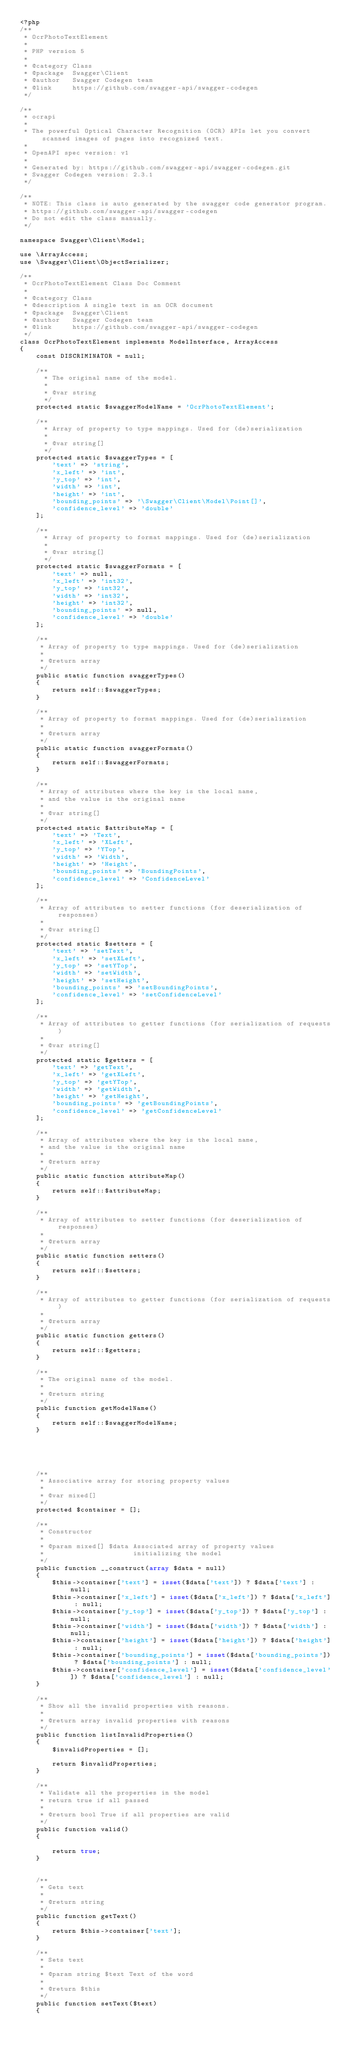Convert code to text. <code><loc_0><loc_0><loc_500><loc_500><_PHP_><?php
/**
 * OcrPhotoTextElement
 *
 * PHP version 5
 *
 * @category Class
 * @package  Swagger\Client
 * @author   Swagger Codegen team
 * @link     https://github.com/swagger-api/swagger-codegen
 */

/**
 * ocrapi
 *
 * The powerful Optical Character Recognition (OCR) APIs let you convert scanned images of pages into recognized text.
 *
 * OpenAPI spec version: v1
 * 
 * Generated by: https://github.com/swagger-api/swagger-codegen.git
 * Swagger Codegen version: 2.3.1
 */

/**
 * NOTE: This class is auto generated by the swagger code generator program.
 * https://github.com/swagger-api/swagger-codegen
 * Do not edit the class manually.
 */

namespace Swagger\Client\Model;

use \ArrayAccess;
use \Swagger\Client\ObjectSerializer;

/**
 * OcrPhotoTextElement Class Doc Comment
 *
 * @category Class
 * @description A single text in an OCR document
 * @package  Swagger\Client
 * @author   Swagger Codegen team
 * @link     https://github.com/swagger-api/swagger-codegen
 */
class OcrPhotoTextElement implements ModelInterface, ArrayAccess
{
    const DISCRIMINATOR = null;

    /**
      * The original name of the model.
      *
      * @var string
      */
    protected static $swaggerModelName = 'OcrPhotoTextElement';

    /**
      * Array of property to type mappings. Used for (de)serialization
      *
      * @var string[]
      */
    protected static $swaggerTypes = [
        'text' => 'string',
        'x_left' => 'int',
        'y_top' => 'int',
        'width' => 'int',
        'height' => 'int',
        'bounding_points' => '\Swagger\Client\Model\Point[]',
        'confidence_level' => 'double'
    ];

    /**
      * Array of property to format mappings. Used for (de)serialization
      *
      * @var string[]
      */
    protected static $swaggerFormats = [
        'text' => null,
        'x_left' => 'int32',
        'y_top' => 'int32',
        'width' => 'int32',
        'height' => 'int32',
        'bounding_points' => null,
        'confidence_level' => 'double'
    ];

    /**
     * Array of property to type mappings. Used for (de)serialization
     *
     * @return array
     */
    public static function swaggerTypes()
    {
        return self::$swaggerTypes;
    }

    /**
     * Array of property to format mappings. Used for (de)serialization
     *
     * @return array
     */
    public static function swaggerFormats()
    {
        return self::$swaggerFormats;
    }

    /**
     * Array of attributes where the key is the local name,
     * and the value is the original name
     *
     * @var string[]
     */
    protected static $attributeMap = [
        'text' => 'Text',
        'x_left' => 'XLeft',
        'y_top' => 'YTop',
        'width' => 'Width',
        'height' => 'Height',
        'bounding_points' => 'BoundingPoints',
        'confidence_level' => 'ConfidenceLevel'
    ];

    /**
     * Array of attributes to setter functions (for deserialization of responses)
     *
     * @var string[]
     */
    protected static $setters = [
        'text' => 'setText',
        'x_left' => 'setXLeft',
        'y_top' => 'setYTop',
        'width' => 'setWidth',
        'height' => 'setHeight',
        'bounding_points' => 'setBoundingPoints',
        'confidence_level' => 'setConfidenceLevel'
    ];

    /**
     * Array of attributes to getter functions (for serialization of requests)
     *
     * @var string[]
     */
    protected static $getters = [
        'text' => 'getText',
        'x_left' => 'getXLeft',
        'y_top' => 'getYTop',
        'width' => 'getWidth',
        'height' => 'getHeight',
        'bounding_points' => 'getBoundingPoints',
        'confidence_level' => 'getConfidenceLevel'
    ];

    /**
     * Array of attributes where the key is the local name,
     * and the value is the original name
     *
     * @return array
     */
    public static function attributeMap()
    {
        return self::$attributeMap;
    }

    /**
     * Array of attributes to setter functions (for deserialization of responses)
     *
     * @return array
     */
    public static function setters()
    {
        return self::$setters;
    }

    /**
     * Array of attributes to getter functions (for serialization of requests)
     *
     * @return array
     */
    public static function getters()
    {
        return self::$getters;
    }

    /**
     * The original name of the model.
     *
     * @return string
     */
    public function getModelName()
    {
        return self::$swaggerModelName;
    }

    

    

    /**
     * Associative array for storing property values
     *
     * @var mixed[]
     */
    protected $container = [];

    /**
     * Constructor
     *
     * @param mixed[] $data Associated array of property values
     *                      initializing the model
     */
    public function __construct(array $data = null)
    {
        $this->container['text'] = isset($data['text']) ? $data['text'] : null;
        $this->container['x_left'] = isset($data['x_left']) ? $data['x_left'] : null;
        $this->container['y_top'] = isset($data['y_top']) ? $data['y_top'] : null;
        $this->container['width'] = isset($data['width']) ? $data['width'] : null;
        $this->container['height'] = isset($data['height']) ? $data['height'] : null;
        $this->container['bounding_points'] = isset($data['bounding_points']) ? $data['bounding_points'] : null;
        $this->container['confidence_level'] = isset($data['confidence_level']) ? $data['confidence_level'] : null;
    }

    /**
     * Show all the invalid properties with reasons.
     *
     * @return array invalid properties with reasons
     */
    public function listInvalidProperties()
    {
        $invalidProperties = [];

        return $invalidProperties;
    }

    /**
     * Validate all the properties in the model
     * return true if all passed
     *
     * @return bool True if all properties are valid
     */
    public function valid()
    {

        return true;
    }


    /**
     * Gets text
     *
     * @return string
     */
    public function getText()
    {
        return $this->container['text'];
    }

    /**
     * Sets text
     *
     * @param string $text Text of the word
     *
     * @return $this
     */
    public function setText($text)
    {</code> 